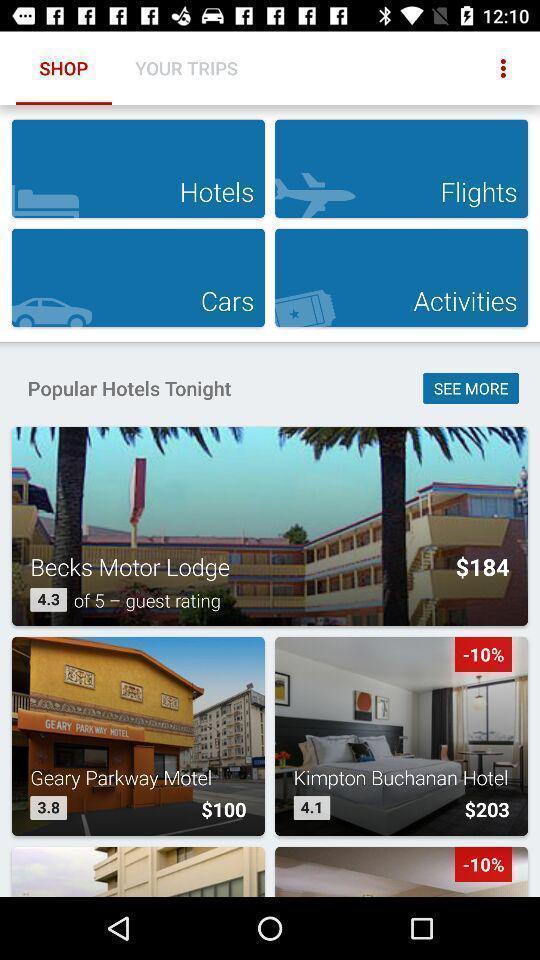What can you discern from this picture? Screen showing shop page of a travel app. 